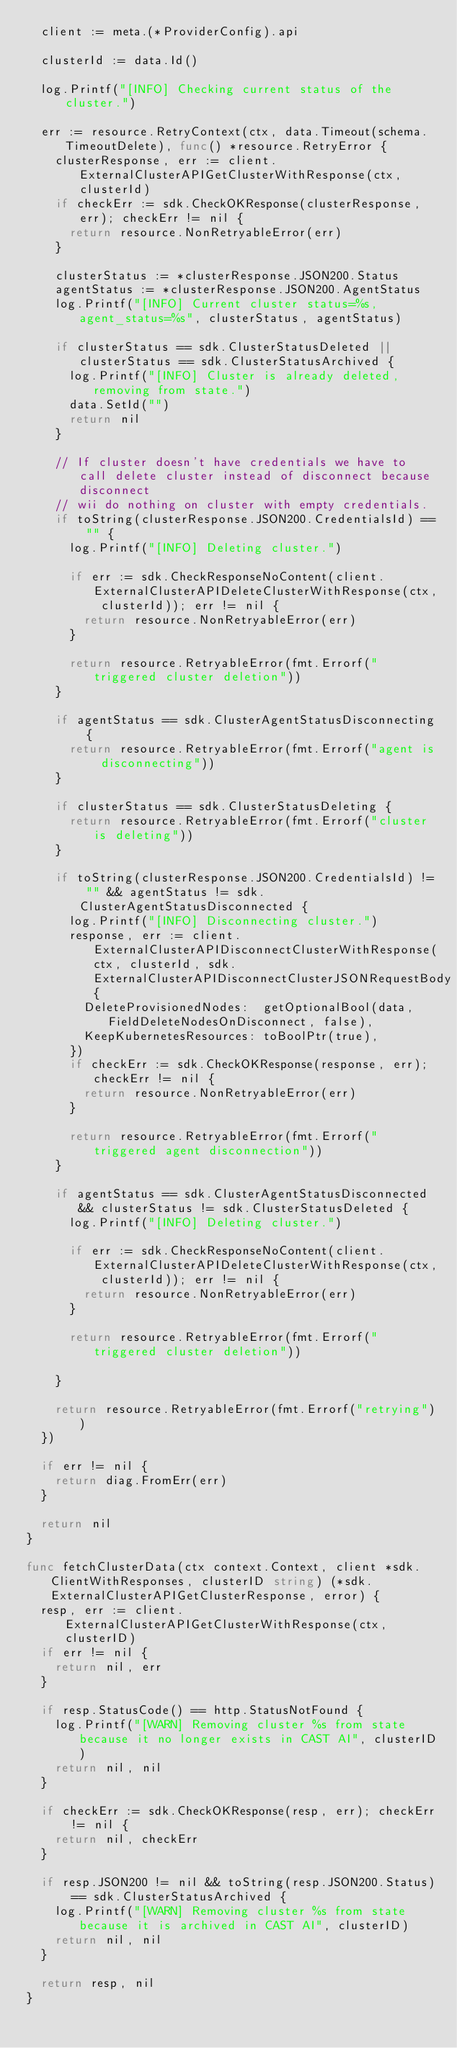<code> <loc_0><loc_0><loc_500><loc_500><_Go_>	client := meta.(*ProviderConfig).api

	clusterId := data.Id()

	log.Printf("[INFO] Checking current status of the cluster.")

	err := resource.RetryContext(ctx, data.Timeout(schema.TimeoutDelete), func() *resource.RetryError {
		clusterResponse, err := client.ExternalClusterAPIGetClusterWithResponse(ctx, clusterId)
		if checkErr := sdk.CheckOKResponse(clusterResponse, err); checkErr != nil {
			return resource.NonRetryableError(err)
		}

		clusterStatus := *clusterResponse.JSON200.Status
		agentStatus := *clusterResponse.JSON200.AgentStatus
		log.Printf("[INFO] Current cluster status=%s, agent_status=%s", clusterStatus, agentStatus)

		if clusterStatus == sdk.ClusterStatusDeleted || clusterStatus == sdk.ClusterStatusArchived {
			log.Printf("[INFO] Cluster is already deleted, removing from state.")
			data.SetId("")
			return nil
		}

		// If cluster doesn't have credentials we have to call delete cluster instead of disconnect because disconnect
		// wii do nothing on cluster with empty credentials.
		if toString(clusterResponse.JSON200.CredentialsId) == "" {
			log.Printf("[INFO] Deleting cluster.")

			if err := sdk.CheckResponseNoContent(client.ExternalClusterAPIDeleteClusterWithResponse(ctx, clusterId)); err != nil {
				return resource.NonRetryableError(err)
			}

			return resource.RetryableError(fmt.Errorf("triggered cluster deletion"))
		}

		if agentStatus == sdk.ClusterAgentStatusDisconnecting {
			return resource.RetryableError(fmt.Errorf("agent is disconnecting"))
		}

		if clusterStatus == sdk.ClusterStatusDeleting {
			return resource.RetryableError(fmt.Errorf("cluster is deleting"))
		}

		if toString(clusterResponse.JSON200.CredentialsId) != "" && agentStatus != sdk.ClusterAgentStatusDisconnected {
			log.Printf("[INFO] Disconnecting cluster.")
			response, err := client.ExternalClusterAPIDisconnectClusterWithResponse(ctx, clusterId, sdk.ExternalClusterAPIDisconnectClusterJSONRequestBody{
				DeleteProvisionedNodes:  getOptionalBool(data, FieldDeleteNodesOnDisconnect, false),
				KeepKubernetesResources: toBoolPtr(true),
			})
			if checkErr := sdk.CheckOKResponse(response, err); checkErr != nil {
				return resource.NonRetryableError(err)
			}

			return resource.RetryableError(fmt.Errorf("triggered agent disconnection"))
		}

		if agentStatus == sdk.ClusterAgentStatusDisconnected && clusterStatus != sdk.ClusterStatusDeleted {
			log.Printf("[INFO] Deleting cluster.")

			if err := sdk.CheckResponseNoContent(client.ExternalClusterAPIDeleteClusterWithResponse(ctx, clusterId)); err != nil {
				return resource.NonRetryableError(err)
			}

			return resource.RetryableError(fmt.Errorf("triggered cluster deletion"))

		}

		return resource.RetryableError(fmt.Errorf("retrying"))
	})

	if err != nil {
		return diag.FromErr(err)
	}

	return nil
}

func fetchClusterData(ctx context.Context, client *sdk.ClientWithResponses, clusterID string) (*sdk.ExternalClusterAPIGetClusterResponse, error) {
	resp, err := client.ExternalClusterAPIGetClusterWithResponse(ctx, clusterID)
	if err != nil {
		return nil, err
	}

	if resp.StatusCode() == http.StatusNotFound {
		log.Printf("[WARN] Removing cluster %s from state because it no longer exists in CAST AI", clusterID)
		return nil, nil
	}

	if checkErr := sdk.CheckOKResponse(resp, err); checkErr != nil {
		return nil, checkErr
	}

	if resp.JSON200 != nil && toString(resp.JSON200.Status) == sdk.ClusterStatusArchived {
		log.Printf("[WARN] Removing cluster %s from state because it is archived in CAST AI", clusterID)
		return nil, nil
	}

	return resp, nil
}
</code> 